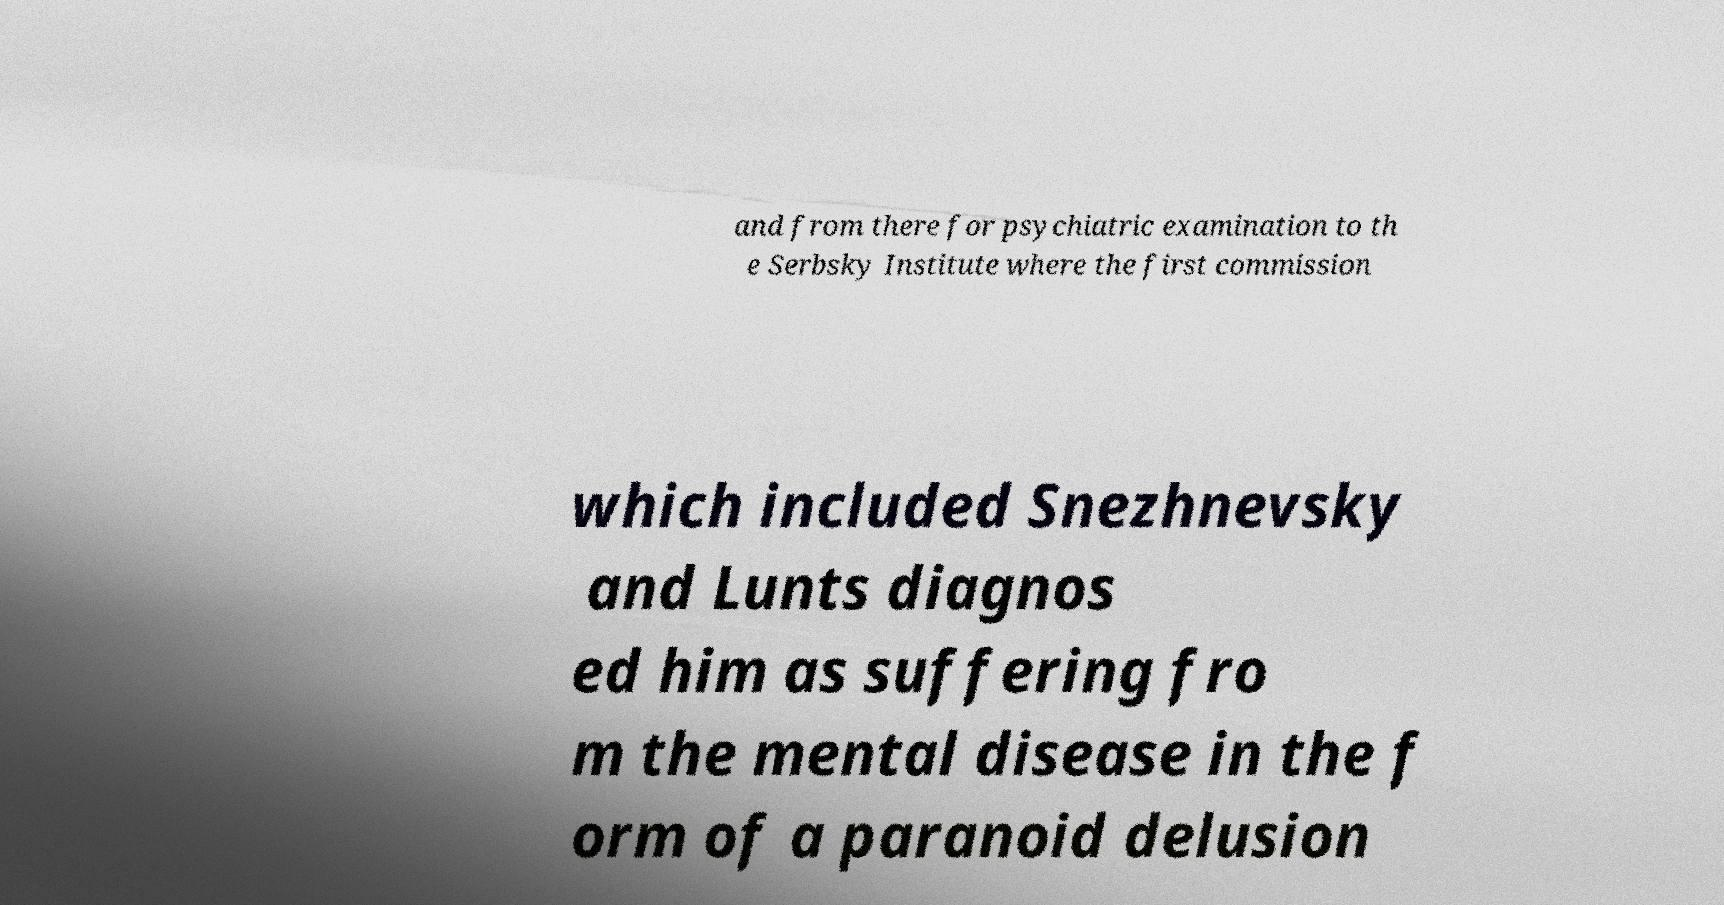I need the written content from this picture converted into text. Can you do that? and from there for psychiatric examination to th e Serbsky Institute where the first commission which included Snezhnevsky and Lunts diagnos ed him as suffering fro m the mental disease in the f orm of a paranoid delusion 